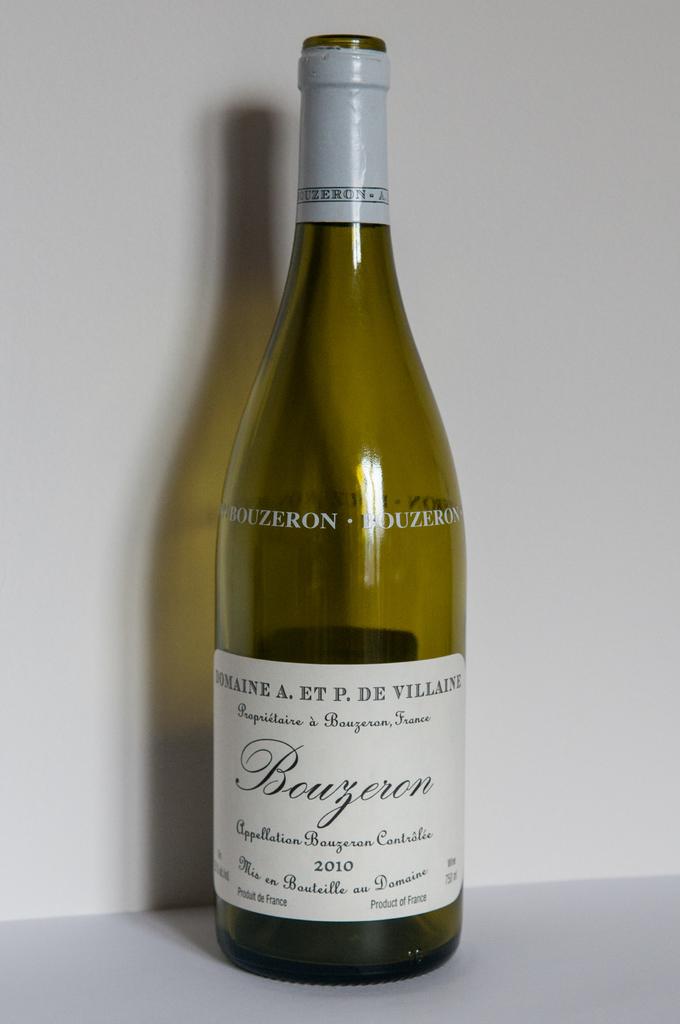When was this bottle made?
Offer a very short reply. 2010. What is the wine name ?
Keep it short and to the point. Bouzeron. 